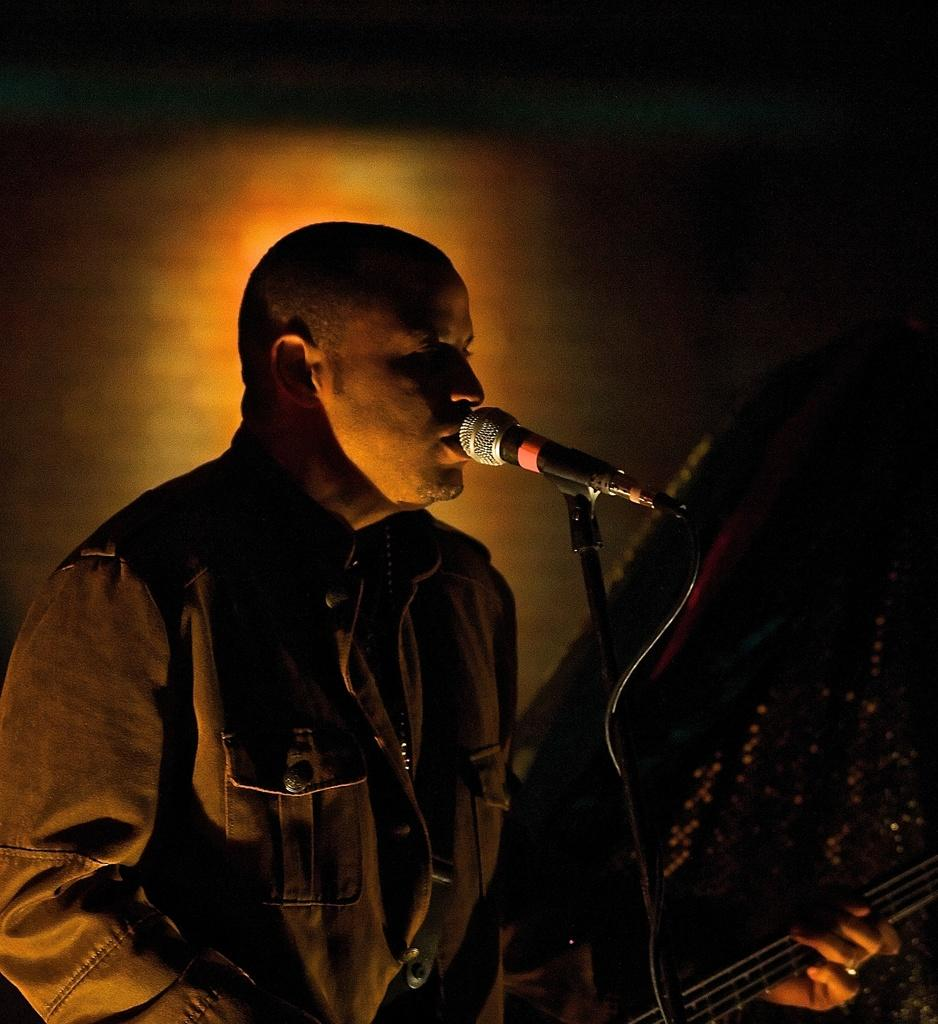What is the main subject of the image? The main subject of the image is a man. What is the man doing in the image? The man is standing, singing, and playing a musical instrument. What object is present to amplify the man's voice? There is a microphone in the image. What is the man using to support his musical instrument? There is a stand in the image. What type of comb is the man using to style his hair in the image? There is no comb visible in the image, and the man's hair is not mentioned in the provided facts. --- Facts: 1. There is a car in the image. 2. The car is red. 3. The car has four wheels. 4. The car has a license plate. 5. The car is parked on the street. Absurd Topics: parrot, sandcastle, volcano Conversation: What is the main subject of the image? The main subject of the image is a car. What color is the car? The car is red. How many wheels does the car have? The car has four wheels. Is there any identifying information on the car? Yes, the car has a license plate. Where is the car located in the image? The car is parked on the street. Reasoning: Let's think step by step in order to produce the conversation. We start by identifying the main subject of the image, which is the car. Then, we describe the car's color, number of wheels, and the presence of a license plate. Finally, we mention the car's location, which is parked on the street. Absurd Question/Answer: Can you see a parrot sitting on the car's roof in the image? No, there is no parrot visible on the car's roof in the image. 